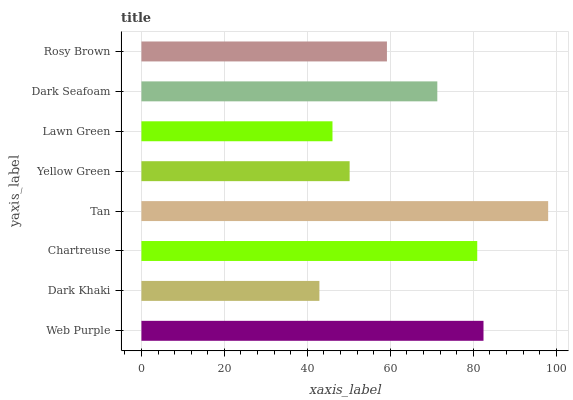Is Dark Khaki the minimum?
Answer yes or no. Yes. Is Tan the maximum?
Answer yes or no. Yes. Is Chartreuse the minimum?
Answer yes or no. No. Is Chartreuse the maximum?
Answer yes or no. No. Is Chartreuse greater than Dark Khaki?
Answer yes or no. Yes. Is Dark Khaki less than Chartreuse?
Answer yes or no. Yes. Is Dark Khaki greater than Chartreuse?
Answer yes or no. No. Is Chartreuse less than Dark Khaki?
Answer yes or no. No. Is Dark Seafoam the high median?
Answer yes or no. Yes. Is Rosy Brown the low median?
Answer yes or no. Yes. Is Chartreuse the high median?
Answer yes or no. No. Is Yellow Green the low median?
Answer yes or no. No. 